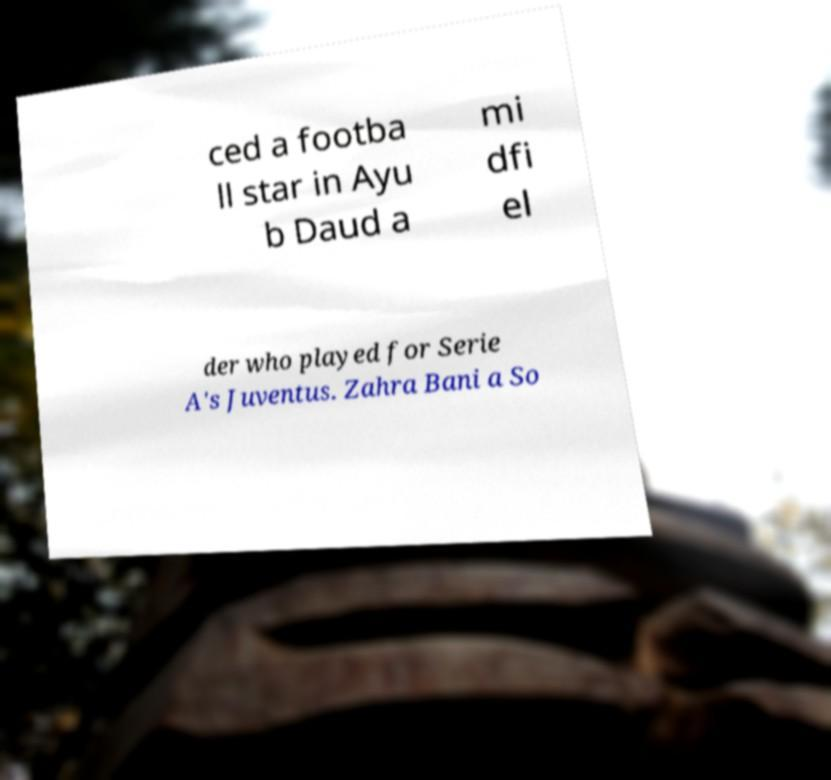Could you extract and type out the text from this image? ced a footba ll star in Ayu b Daud a mi dfi el der who played for Serie A's Juventus. Zahra Bani a So 